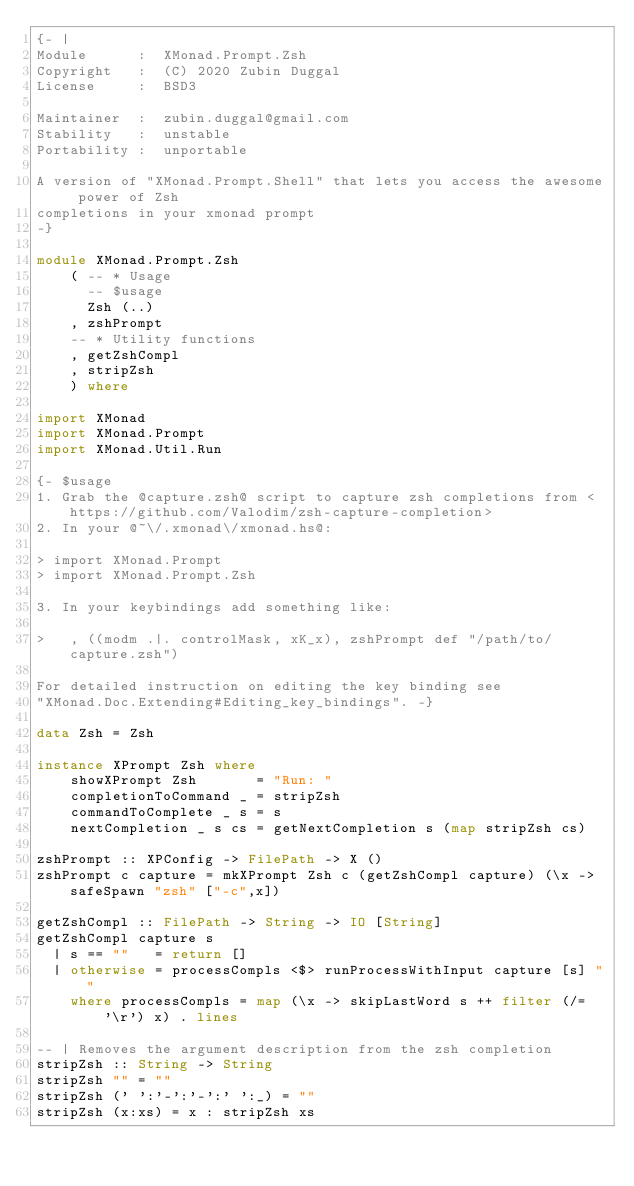Convert code to text. <code><loc_0><loc_0><loc_500><loc_500><_Haskell_>{- |
Module      :  XMonad.Prompt.Zsh
Copyright   :  (C) 2020 Zubin Duggal
License     :  BSD3

Maintainer  :  zubin.duggal@gmail.com
Stability   :  unstable
Portability :  unportable

A version of "XMonad.Prompt.Shell" that lets you access the awesome power of Zsh
completions in your xmonad prompt
-}

module XMonad.Prompt.Zsh
    ( -- * Usage
      -- $usage
      Zsh (..)
    , zshPrompt
    -- * Utility functions
    , getZshCompl
    , stripZsh
    ) where

import XMonad
import XMonad.Prompt
import XMonad.Util.Run

{- $usage
1. Grab the @capture.zsh@ script to capture zsh completions from <https://github.com/Valodim/zsh-capture-completion>
2. In your @~\/.xmonad\/xmonad.hs@:

> import XMonad.Prompt
> import XMonad.Prompt.Zsh

3. In your keybindings add something like:

>   , ((modm .|. controlMask, xK_x), zshPrompt def "/path/to/capture.zsh")

For detailed instruction on editing the key binding see
"XMonad.Doc.Extending#Editing_key_bindings". -}

data Zsh = Zsh

instance XPrompt Zsh where
    showXPrompt Zsh       = "Run: "
    completionToCommand _ = stripZsh
    commandToComplete _ s = s
    nextCompletion _ s cs = getNextCompletion s (map stripZsh cs)

zshPrompt :: XPConfig -> FilePath -> X ()
zshPrompt c capture = mkXPrompt Zsh c (getZshCompl capture) (\x -> safeSpawn "zsh" ["-c",x])

getZshCompl :: FilePath -> String -> IO [String]
getZshCompl capture s
  | s == ""   = return []
  | otherwise = processCompls <$> runProcessWithInput capture [s] ""
    where processCompls = map (\x -> skipLastWord s ++ filter (/= '\r') x) . lines

-- | Removes the argument description from the zsh completion
stripZsh :: String -> String
stripZsh "" = ""
stripZsh (' ':'-':'-':' ':_) = ""
stripZsh (x:xs) = x : stripZsh xs
</code> 